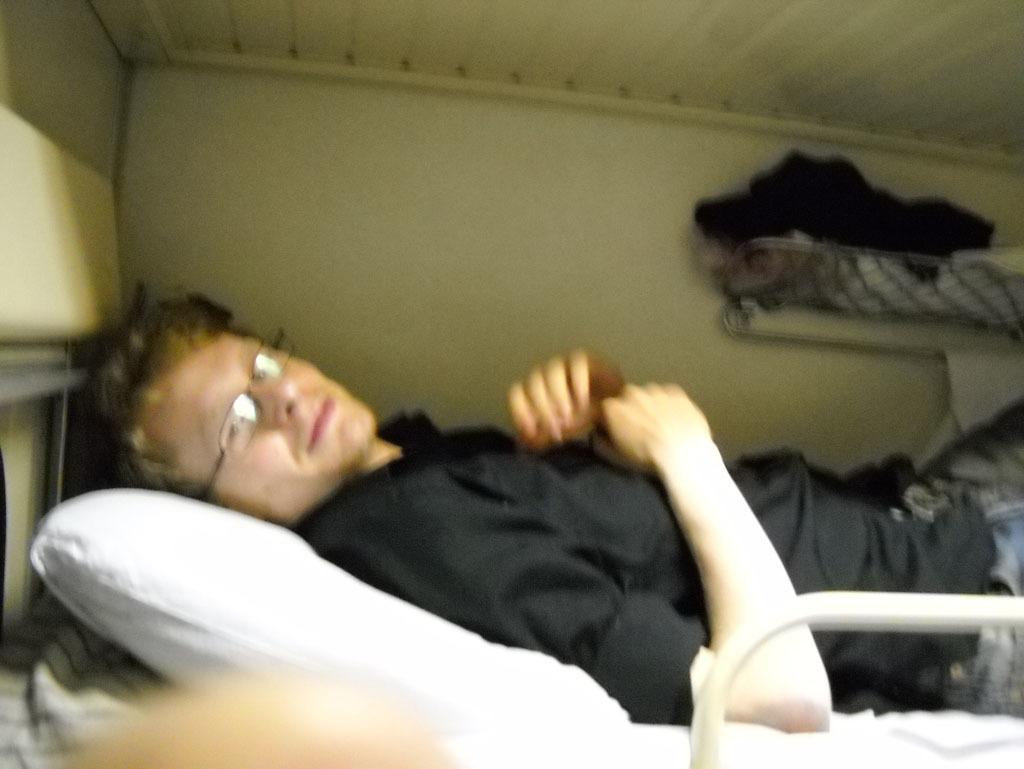Where was the image taken? The image was taken inside a room. Who is present in the image? There is a man in the image. What is the man wearing? The man is wearing a black shirt. What is the man doing in the image? The man is laying on the bed. What can be seen on the right side of the image? There are clothes visible on the right side of the image. What type of writing can be seen on the representative's pin in the image? There is no representative or pin present in the image. 